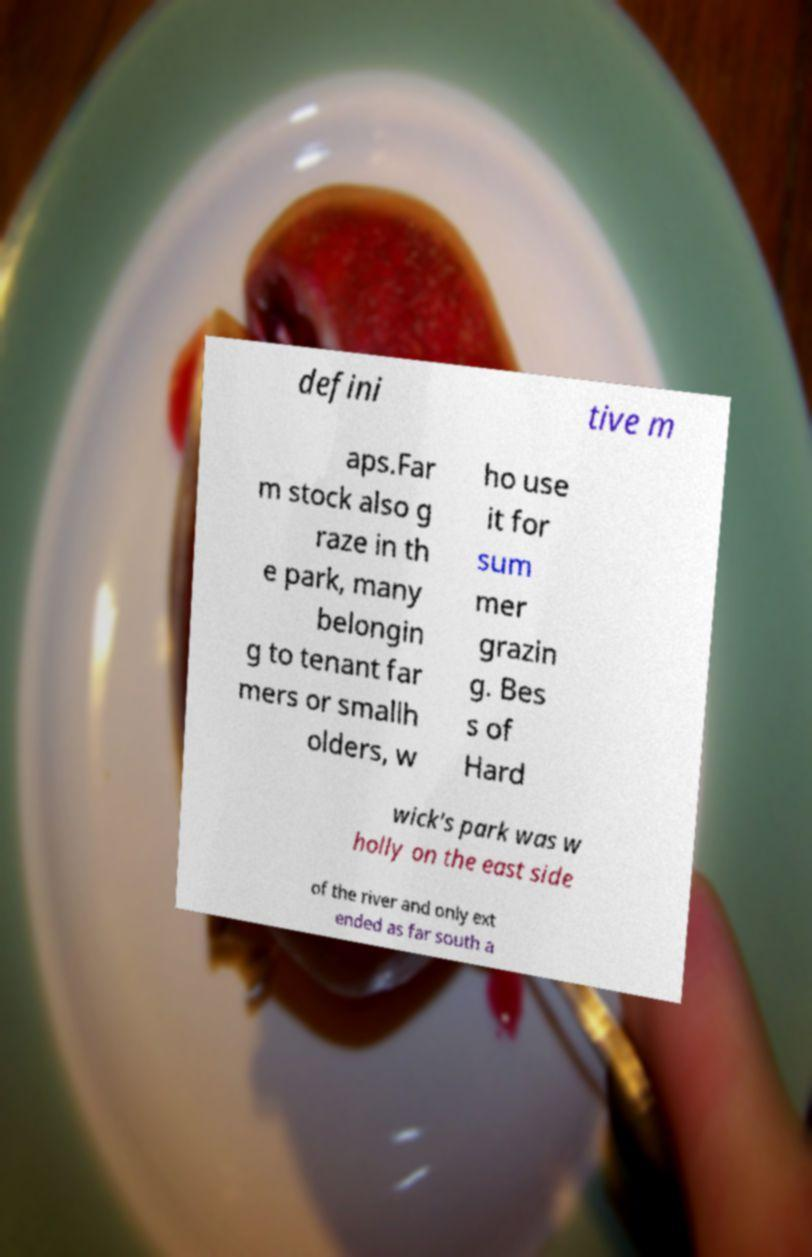Please identify and transcribe the text found in this image. defini tive m aps.Far m stock also g raze in th e park, many belongin g to tenant far mers or smallh olders, w ho use it for sum mer grazin g. Bes s of Hard wick's park was w holly on the east side of the river and only ext ended as far south a 